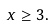Convert formula to latex. <formula><loc_0><loc_0><loc_500><loc_500>x \geq 3 .</formula> 